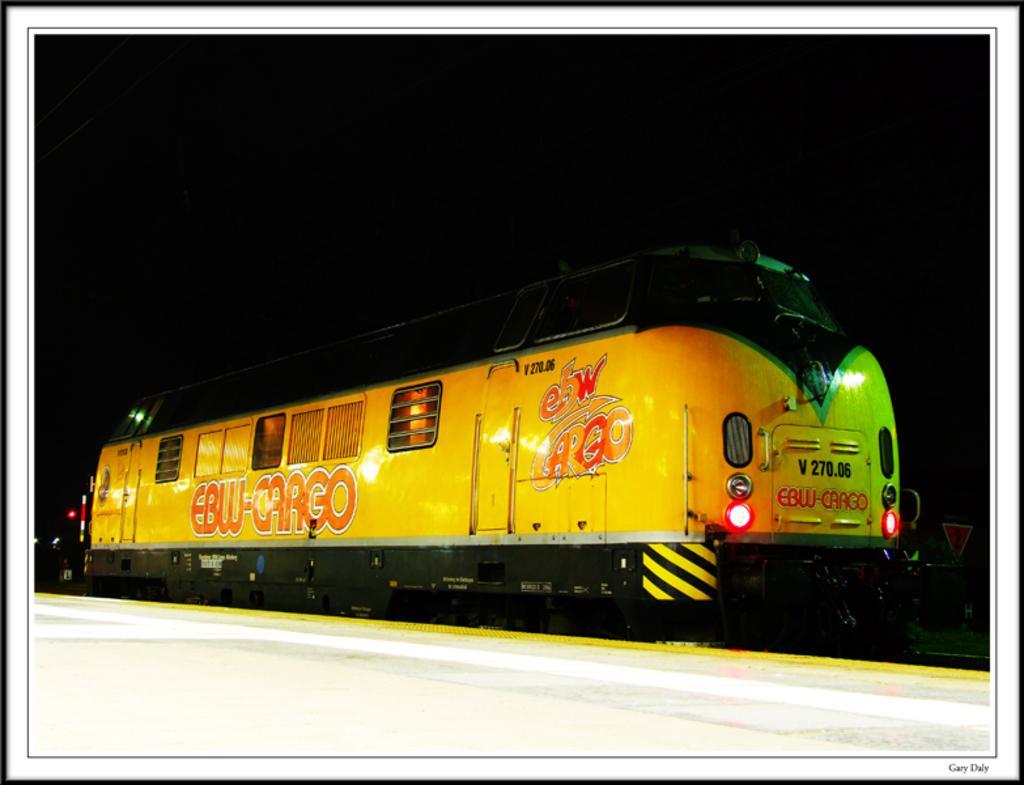Could you give a brief overview of what you see in this image? In this picture I can observe a train on the railway track. There is a platform. The train is in yellow color. The background is completely dark. 